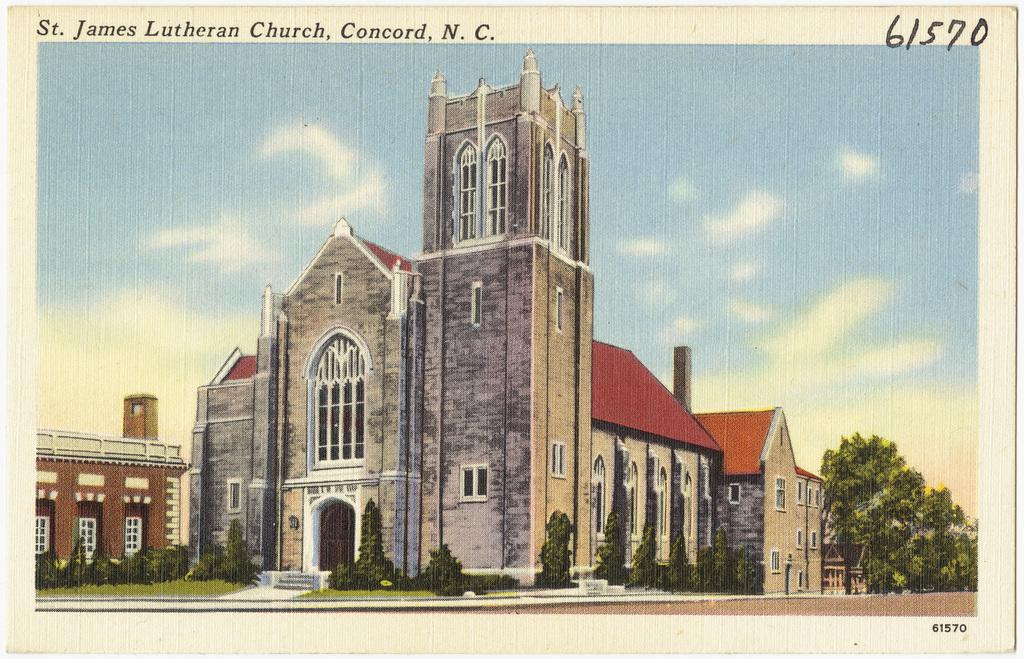What is featured on the poster in the picture? The poster contains a photo of buildings, trees, and the sky. Are there any words on the poster? Yes, there are words on the poster. Are there any numbers on the poster? Yes, there are numbers on the poster. Can you tell me how many dogs are visible in the image? There are no dogs present in the image; the poster contains photos of buildings, trees, and the sky. What type of boundary is depicted in the image? There is no boundary depicted in the image; the poster contains photos of buildings, trees, and the sky, along with words and numbers. 